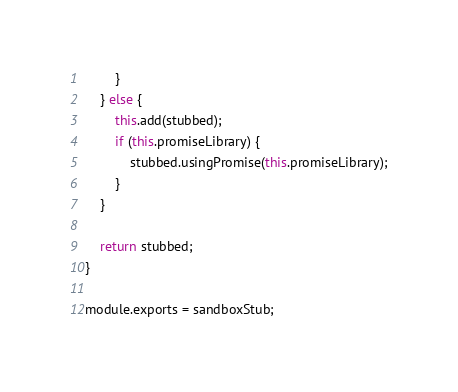Convert code to text. <code><loc_0><loc_0><loc_500><loc_500><_JavaScript_>        }
    } else {
        this.add(stubbed);
        if (this.promiseLibrary) {
            stubbed.usingPromise(this.promiseLibrary);
        }
    }

    return stubbed;
}

module.exports = sandboxStub;
</code> 